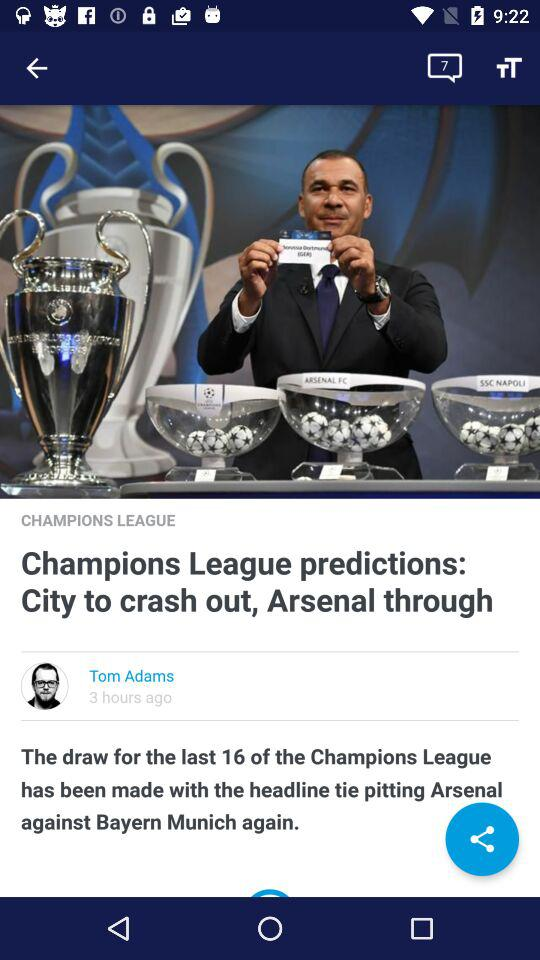How many minutes ago was the draw for the Champions League?
When the provided information is insufficient, respond with <no answer>. <no answer> 